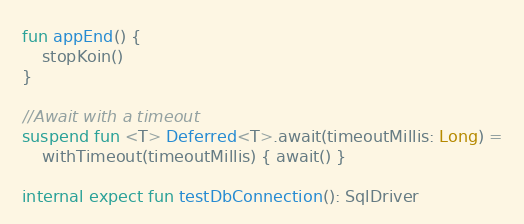<code> <loc_0><loc_0><loc_500><loc_500><_Kotlin_>
fun appEnd() {
    stopKoin()
}

//Await with a timeout
suspend fun <T> Deferred<T>.await(timeoutMillis: Long) =
    withTimeout(timeoutMillis) { await() }

internal expect fun testDbConnection(): SqlDriver

</code> 